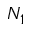<formula> <loc_0><loc_0><loc_500><loc_500>N _ { 1 }</formula> 